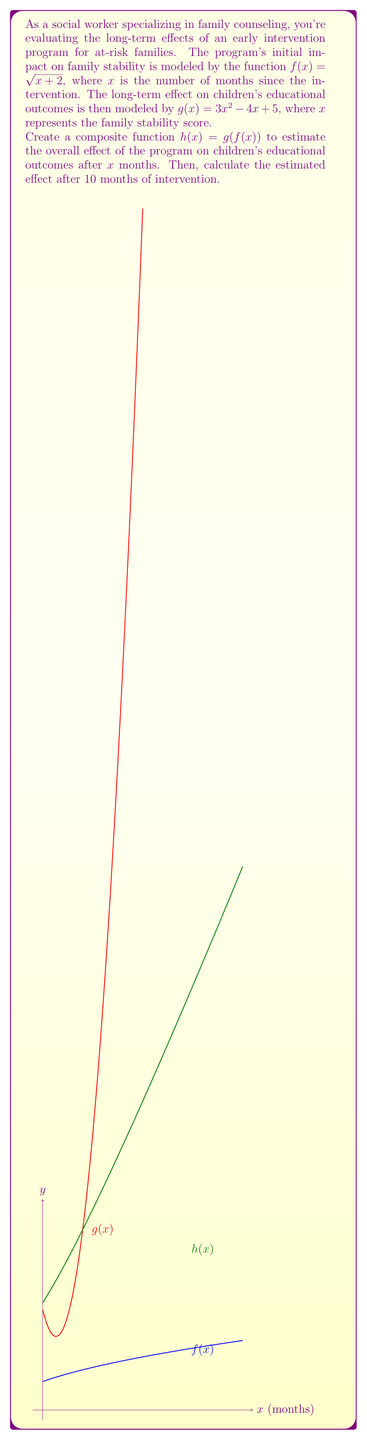What is the answer to this math problem? Let's approach this step-by-step:

1) We need to create the composite function $h(x) = g(f(x))$. This means we replace every $x$ in $g(x)$ with $f(x)$.

2) $f(x) = \sqrt{x + 2}$
   $g(x) = 3x^2 - 4x + 5$

3) Substituting $f(x)$ into $g(x)$:
   $h(x) = g(f(x)) = 3(\sqrt{x + 2})^2 - 4(\sqrt{x + 2}) + 5$

4) Simplify:
   $h(x) = 3(x + 2) - 4\sqrt{x + 2} + 5$
   $h(x) = 3x + 6 - 4\sqrt{x + 2} + 5$
   $h(x) = 3x - 4\sqrt{x + 2} + 11$

5) Now we have our composite function. To estimate the effect after 10 months, we need to calculate $h(10)$:

   $h(10) = 3(10) - 4\sqrt{10 + 2} + 11$
   $h(10) = 30 - 4\sqrt{12} + 11$
   $h(10) = 30 - 4(2\sqrt{3}) + 11$
   $h(10) = 41 - 8\sqrt{3}$

6) This value represents the estimated effect on children's educational outcomes after 10 months of intervention.
Answer: $h(x) = 3x - 4\sqrt{x + 2} + 11$; $h(10) = 41 - 8\sqrt{3}$ 